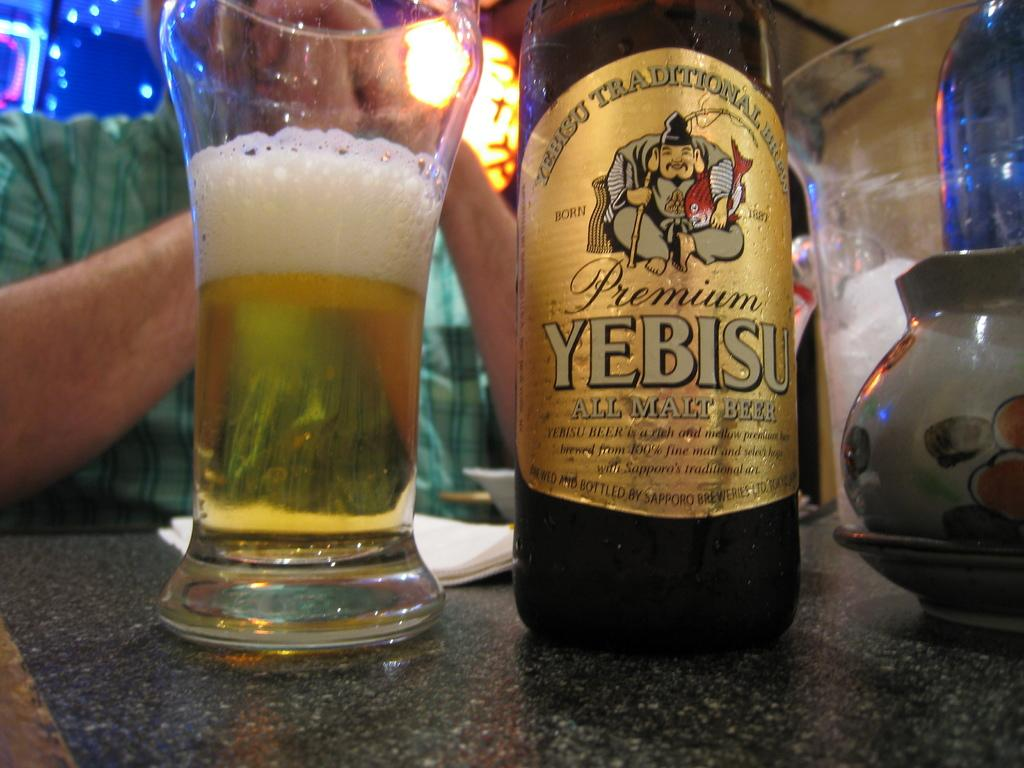<image>
Relay a brief, clear account of the picture shown. A bottle of Yebisu malt beer sits next to a glass. 